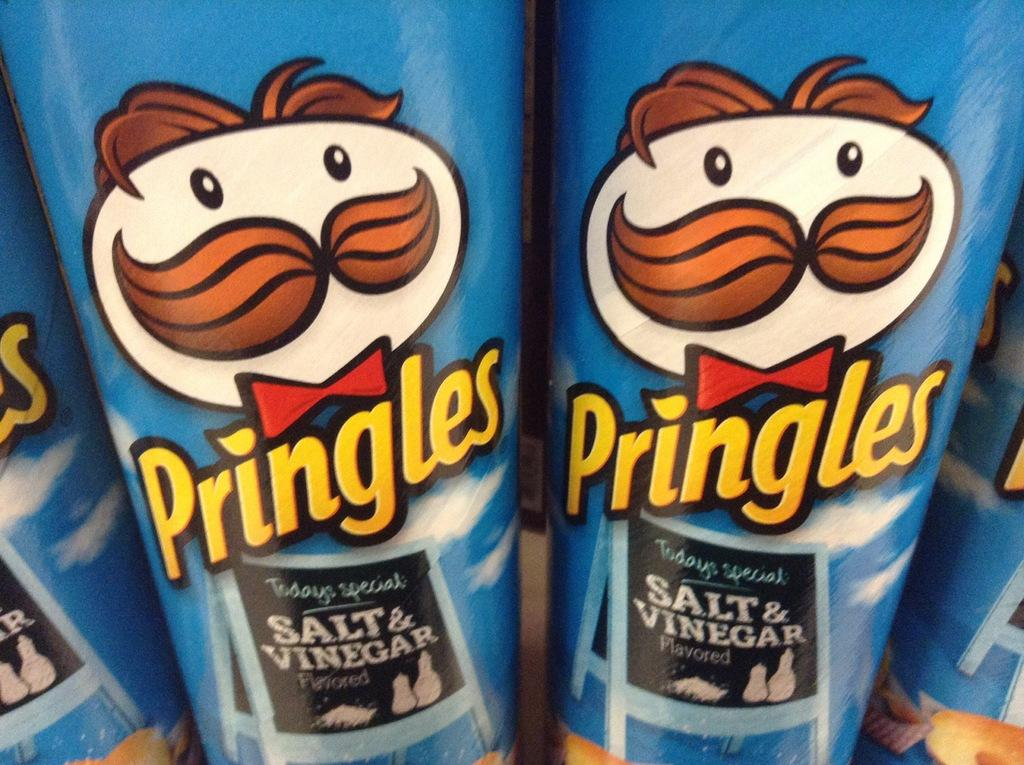What color are the boxes in the image? The boxes in the image are blue. What is present on the surface of the boxes? There is writing on the boxes. How many chairs are visible in the image? There are no chairs visible in the image; it only features blue color boxes with writing on them. 